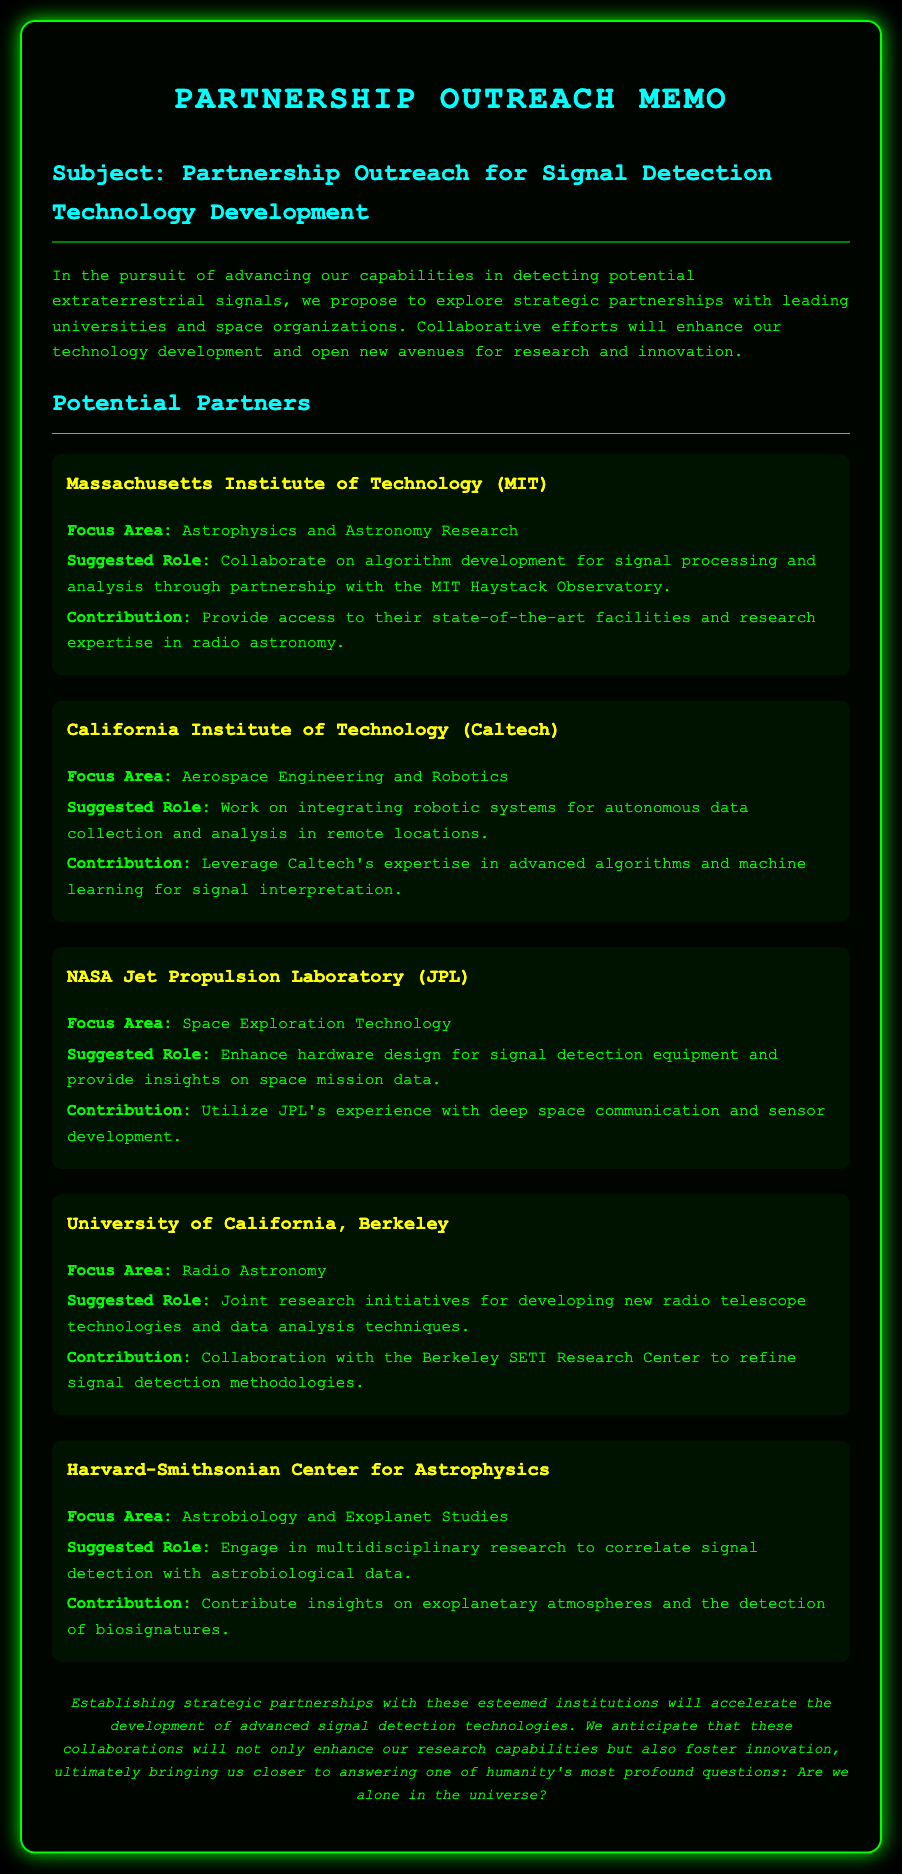what is the title of the memo? The title of the memo is presented prominently at the top of the document.
Answer: Partnership Outreach Memo who is the suggested partner focused on Astrophysics and Astronomy Research? The document lists several potential partners, specifying who focuses on which area.
Answer: Massachusetts Institute of Technology (MIT) what is the primary focus area of Caltech? The document mentions each partner's focus area clearly in their respective sections.
Answer: Aerospace Engineering and Robotics what is the suggested role for NASA Jet Propulsion Laboratory? The role is indicated under each potential partner's description in the document.
Answer: Enhance hardware design for signal detection equipment which institution is associated with the Berkeley SETI Research Center? The relationships and collaborations are highlighted for relevant organizations within the memo.
Answer: University of California, Berkeley how many potential partners are listed in the document? The document enumerates the potential partners, making this easily countable.
Answer: Five what is the focus area of Harvard-Smithsonian Center for Astrophysics? The partner’s research focus is stated clearly in the document.
Answer: Astrobiology and Exoplanet Studies what is the conclusion of the memo about partnerships? The conclusion summarizes the purpose and anticipated outcomes of the partnerships discussed.
Answer: Establishing strategic partnerships will accelerate the development of advanced signal detection technologies 